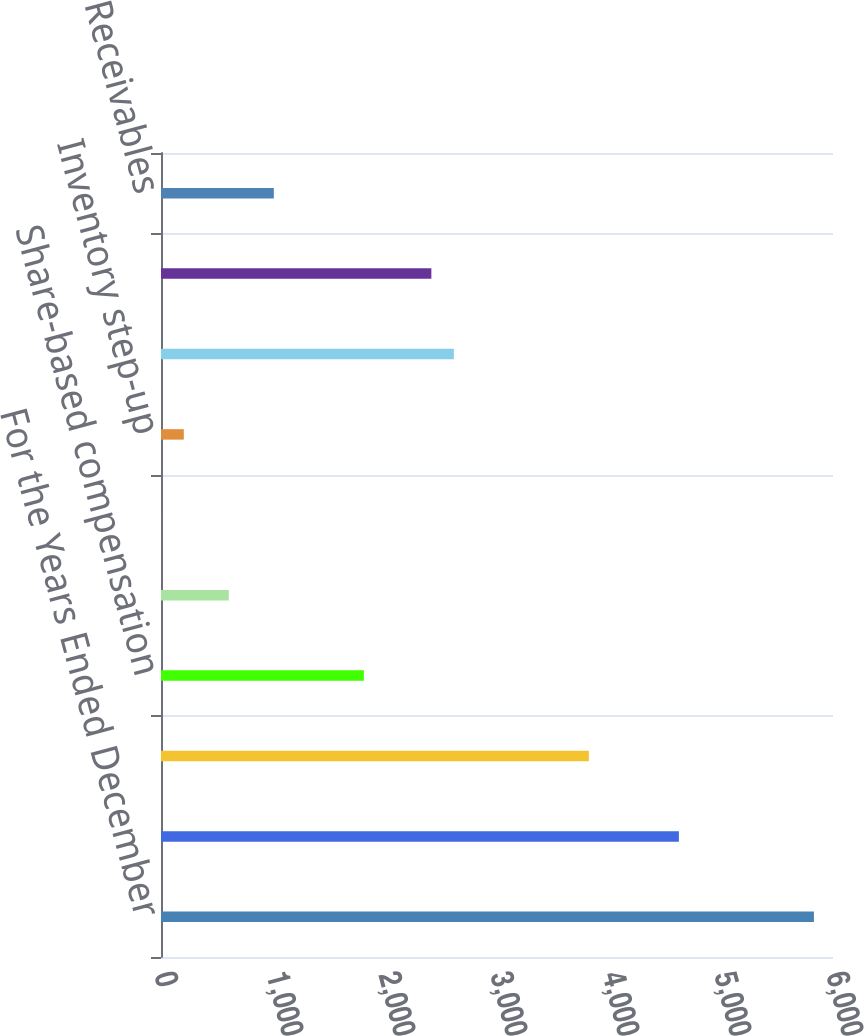Convert chart to OTSL. <chart><loc_0><loc_0><loc_500><loc_500><bar_chart><fcel>For the Years Ended December<fcel>Net earnings<fcel>Depreciation and amortization<fcel>Share-based compensation<fcel>Income tax benefit from stock<fcel>Excess income tax benefit from<fcel>Inventory step-up<fcel>Deferred income tax provision<fcel>Income taxes payable<fcel>Receivables<nl><fcel>5829.67<fcel>4624.09<fcel>3820.37<fcel>1811.07<fcel>605.49<fcel>2.7<fcel>203.63<fcel>2614.79<fcel>2413.86<fcel>1007.35<nl></chart> 